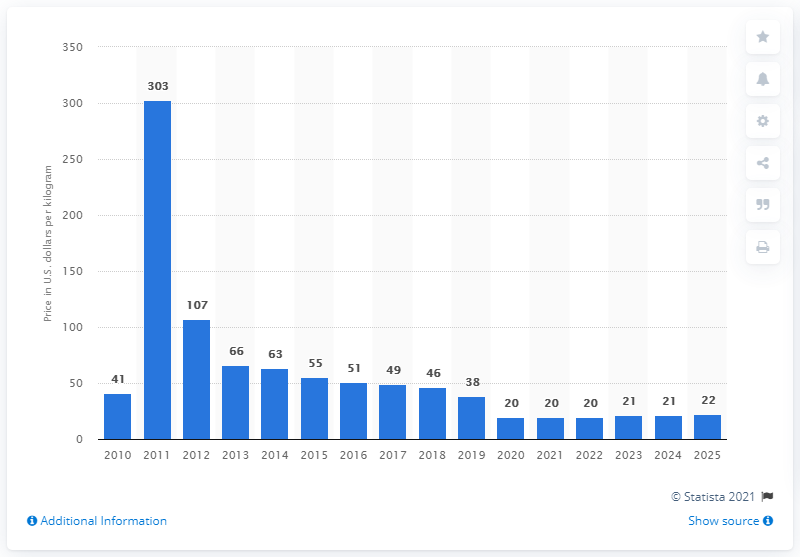Give some essential details in this illustration. The expected price per kilogram of holmium oxide is 49. 